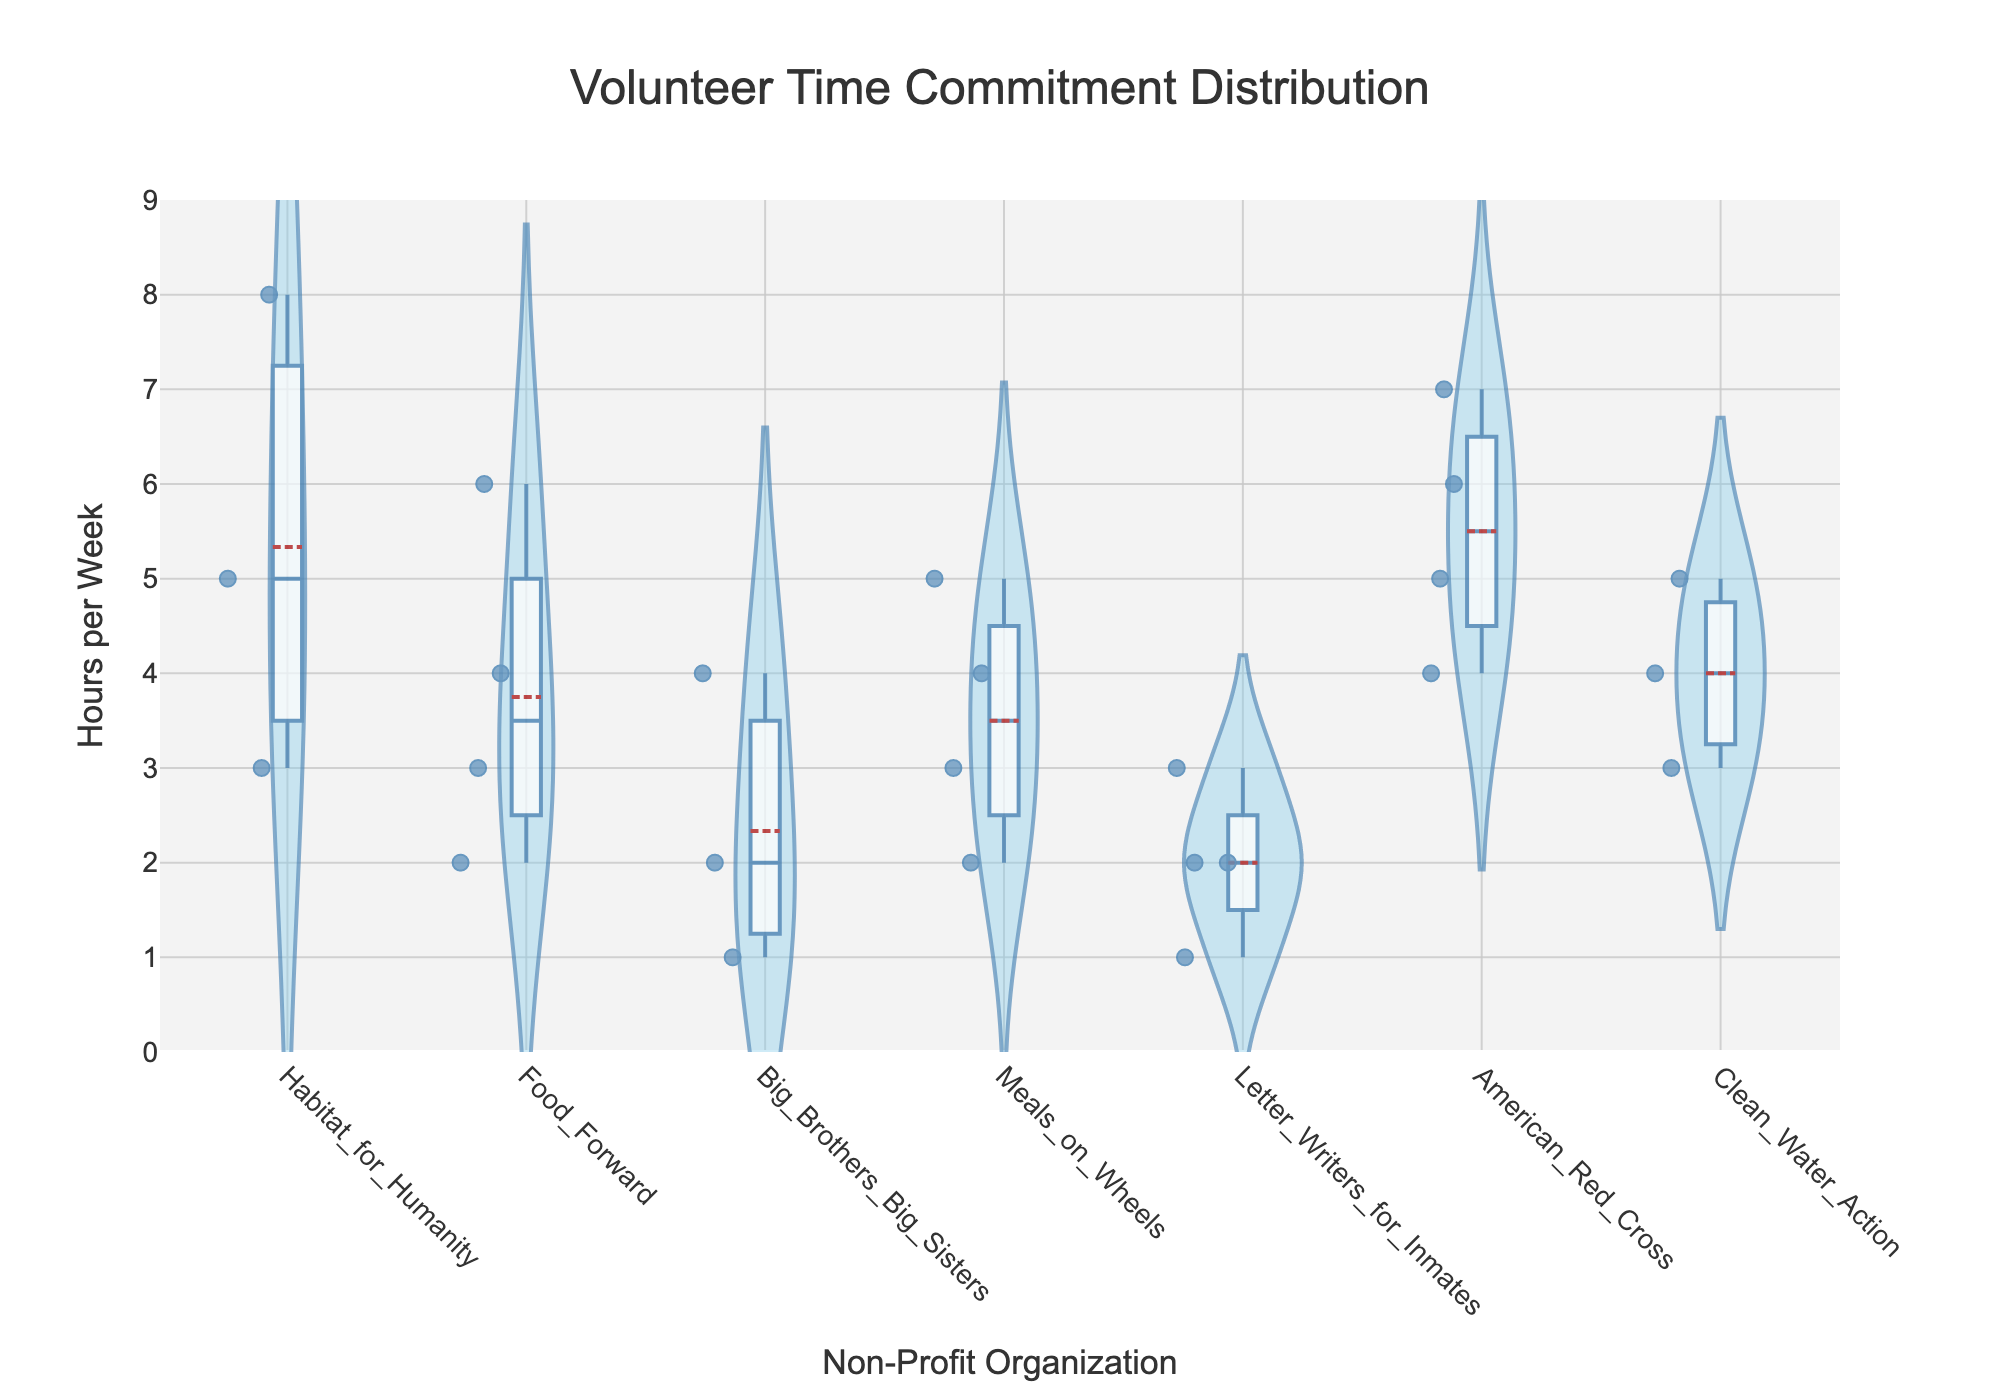What is the title of the violin chart? The title of the chart is displayed at the top center and reads "Volunteer Time Commitment Distribution".
Answer: Volunteer Time Commitment Distribution Which non-profit organization has the highest median volunteer hours per week? To determine the median, observe the white dot in each violin plot that represents the median value. The American Red Cross displays the highest median value.
Answer: American Red Cross How many non-profit organizations are shown in the violin chart? Look at the x-axis to see the different categories representing each organization. There are six organizations listed.
Answer: Six Which non-profit organization shows the widest range of volunteer hours? The range is represented by the vertical span of each violin plot. Habitat for Humanity shows the widest range from the lowest to the highest volunteer hours.
Answer: Habitat for Humanity What is the interquartile range (IQR) for Meals on Wheels? The box in each violin plot represents the IQR. For Meals on Wheels, it extends approximately from 2.5 to 4.5 hours. So, the IQR is 4.5 - 2.5.
Answer: 2 How does the distribution of volunteer hours for Letter Writers for Inmates compare to Big Brothers Big Sisters? Notice the shapes and widths of the violin plots. Letter Writers for Inmates has a more consistent and narrower distribution centered around lower volunteer hours, compared to the scattered hours seen in Big Brothers Big Sisters.
Answer: Letter Writers for Inmates shows a narrower distribution around lower hours; Big Brothers Big Sisters has more variability Are outliers present in the Food Forward dataset? Outliers are represented by individual points outside the main range of the violin plot. In the Food Forward plot, there are no such points visible.
Answer: No Which non-profit organization has the smallest spread of volunteer hours? The spread refers to the width of the distribution in the violin plot. Letter Writers for Inmates has the smallest spread, indicated by its narrow width.
Answer: Letter Writers for Inmates What is the mean volunteer hours per week for Clean Water Action? The mean is indicated by a horizontal line within the violin plot. For Clean Water Action, this line appears at approximately 4 hours per week.
Answer: 4 Comparing the volunteer hours, which non-profit organization tends to attract volunteers who commit more time weekly? Look at the locations and spreads of the distributions. The American Red Cross attracts volunteers who commit more hours weekly, with its plot showing higher values and a higher median.
Answer: American Red Cross 